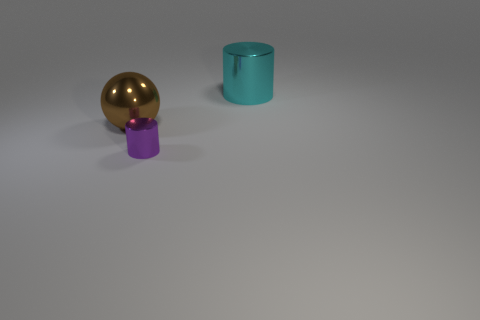Is there a red sphere that has the same size as the brown object?
Your response must be concise. No. Does the cylinder that is behind the tiny cylinder have the same material as the small cylinder?
Provide a short and direct response. Yes. Are any purple metallic objects visible?
Your response must be concise. Yes. There is a tiny thing that is the same material as the ball; what color is it?
Ensure brevity in your answer.  Purple. What is the color of the cylinder that is to the right of the cylinder that is in front of the big metal thing that is left of the purple metallic thing?
Provide a short and direct response. Cyan. Do the shiny sphere and the object to the right of the small cylinder have the same size?
Provide a short and direct response. Yes. What number of objects are either things in front of the brown ball or big things that are left of the big cyan shiny object?
Provide a succinct answer. 2. What is the shape of the other thing that is the same size as the cyan metal object?
Make the answer very short. Sphere. There is a object that is on the right side of the cylinder left of the thing that is right of the purple metallic cylinder; what shape is it?
Ensure brevity in your answer.  Cylinder. Is the number of brown balls that are to the right of the cyan shiny cylinder the same as the number of large things?
Offer a terse response. No. 